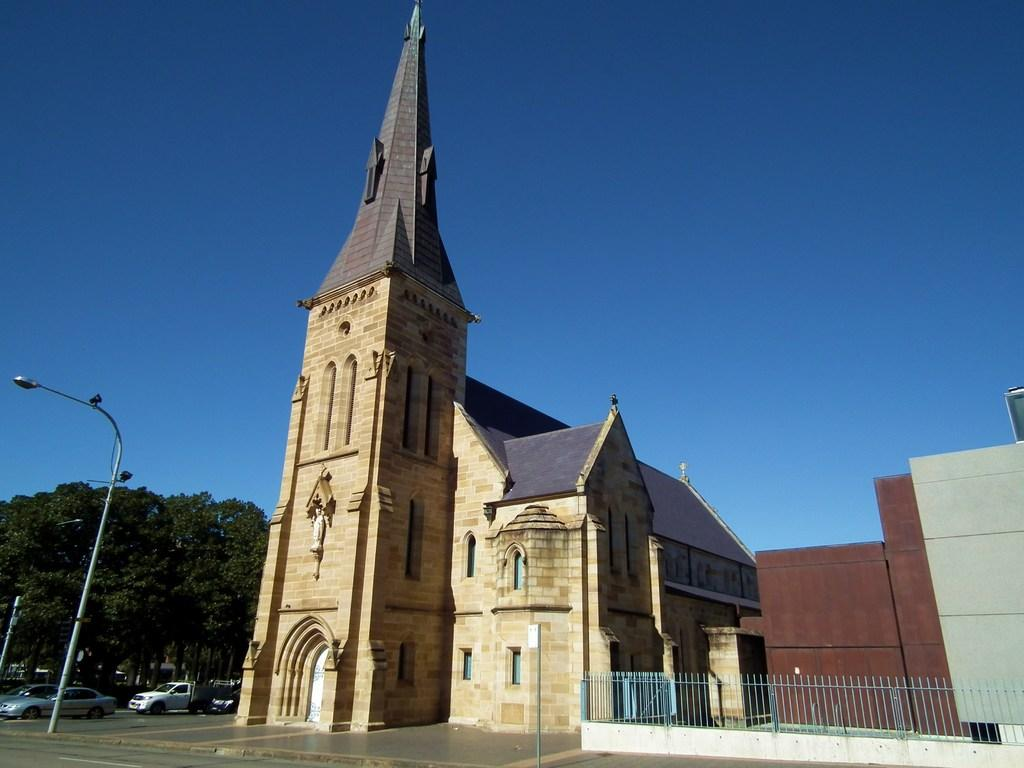What structures can be seen in the image? There are poles, buildings, and a sculpture in the image. What type of light is present in the image? There is a light in the image. What can be found on the road in the image? There are vehicles on the road in the image. What type of security feature is present in the image? There are iron grills in the image. What type of vegetation is present in the image? There are trees in the image. What part of the natural environment is visible in the image? The sky is visible in the image. How many tickets are visible in the image? There are no tickets present in the image. What type of coast can be seen in the image? There is no coast present in the image. 